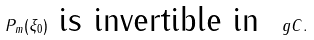Convert formula to latex. <formula><loc_0><loc_0><loc_500><loc_500>P _ { m } ( \xi _ { 0 } ) \text { is invertible in } \ g C .</formula> 